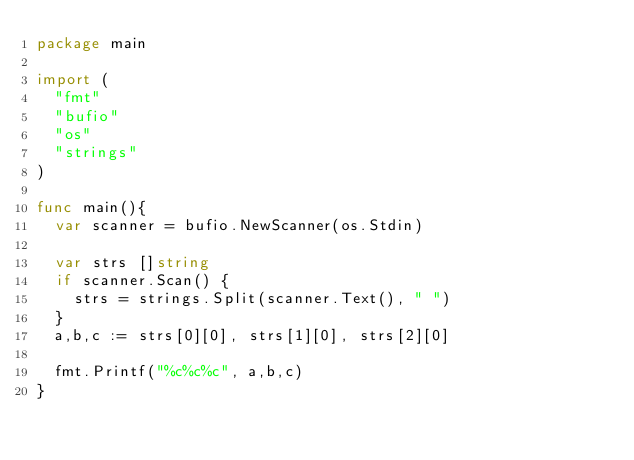<code> <loc_0><loc_0><loc_500><loc_500><_Go_>package main

import (
	"fmt"
	"bufio"
	"os"
	"strings"
)

func main(){
	var scanner = bufio.NewScanner(os.Stdin)

	var strs []string 
	if scanner.Scan() {
		strs = strings.Split(scanner.Text(), " ")
	}
	a,b,c := strs[0][0], strs[1][0], strs[2][0]
	
	fmt.Printf("%c%c%c", a,b,c)
}</code> 